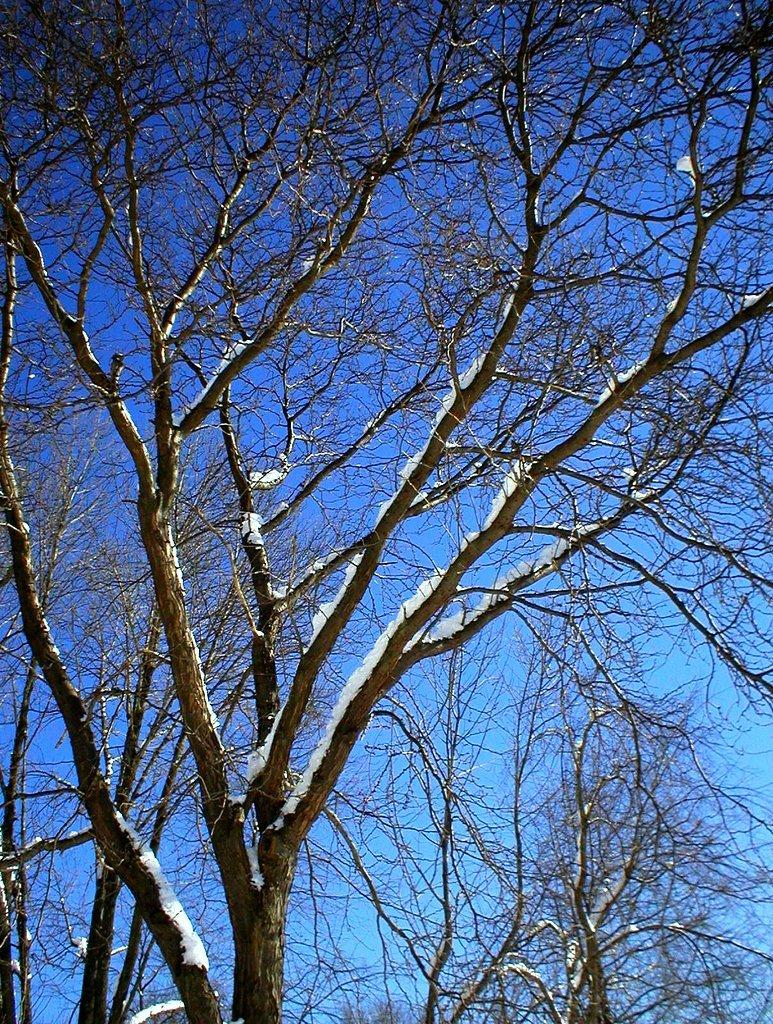What is the main object in the image? There is a tree in the image. What is the color of the tree? The tree is brown in color. What is covering the tree? There is snow on the tree. What can be seen in the background of the image? There are trees and the sky visible in the background of the image. What type of guitar is being played under the tree in the image? There is no guitar or person playing it in the image; it only features a tree with snow on it. On which side of the tree is the umbrella placed in the image? There is no umbrella present in the image. 